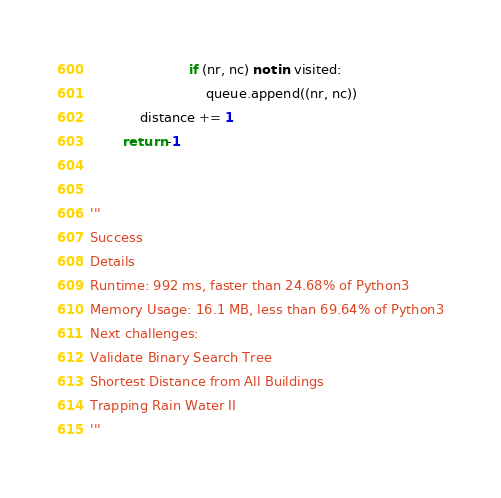Convert code to text. <code><loc_0><loc_0><loc_500><loc_500><_Python_>                        if (nr, nc) not in visited:
                            queue.append((nr, nc))
            distance += 1
        return -1


'''
Success
Details
Runtime: 992 ms, faster than 24.68% of Python3
Memory Usage: 16.1 MB, less than 69.64% of Python3
Next challenges:
Validate Binary Search Tree
Shortest Distance from All Buildings
Trapping Rain Water II
'''
</code> 